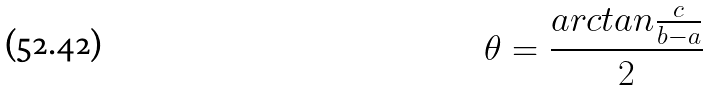<formula> <loc_0><loc_0><loc_500><loc_500>\theta = \frac { a r c t a n \frac { c } { b - a } } { 2 }</formula> 